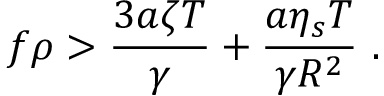<formula> <loc_0><loc_0><loc_500><loc_500>f \rho > \frac { 3 a \zeta T } { \gamma } + \frac { a \eta _ { s } T } { \gamma R ^ { 2 } } \ .</formula> 